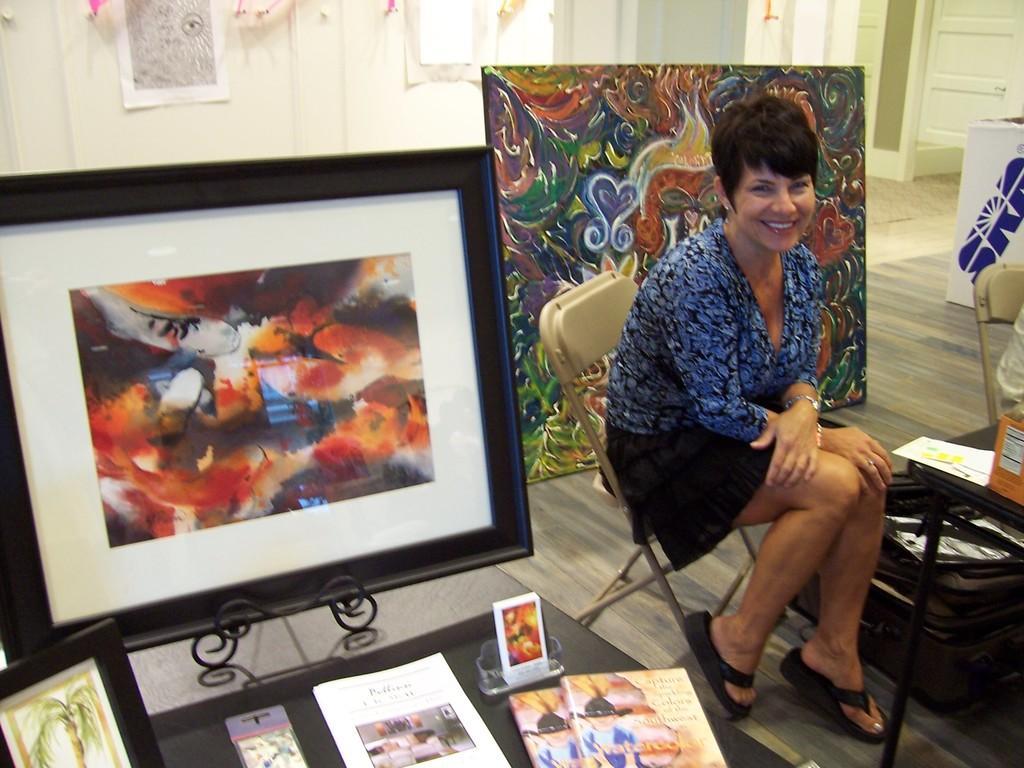Could you give a brief overview of what you see in this image? In this image I can see a woman is sitting on a chair. I can see smile on her face and I can see she is wearing blue top and black slippers. I can also see few paintings, frames, tables, a chair and in background I can see few papers on wall. 